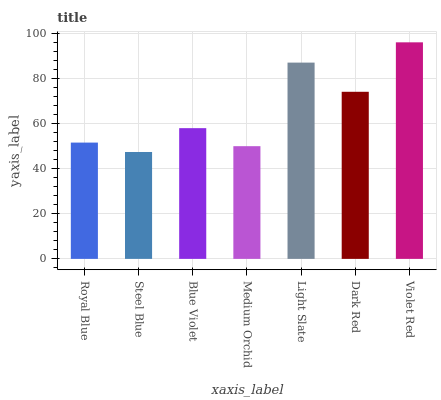Is Steel Blue the minimum?
Answer yes or no. Yes. Is Violet Red the maximum?
Answer yes or no. Yes. Is Blue Violet the minimum?
Answer yes or no. No. Is Blue Violet the maximum?
Answer yes or no. No. Is Blue Violet greater than Steel Blue?
Answer yes or no. Yes. Is Steel Blue less than Blue Violet?
Answer yes or no. Yes. Is Steel Blue greater than Blue Violet?
Answer yes or no. No. Is Blue Violet less than Steel Blue?
Answer yes or no. No. Is Blue Violet the high median?
Answer yes or no. Yes. Is Blue Violet the low median?
Answer yes or no. Yes. Is Medium Orchid the high median?
Answer yes or no. No. Is Light Slate the low median?
Answer yes or no. No. 